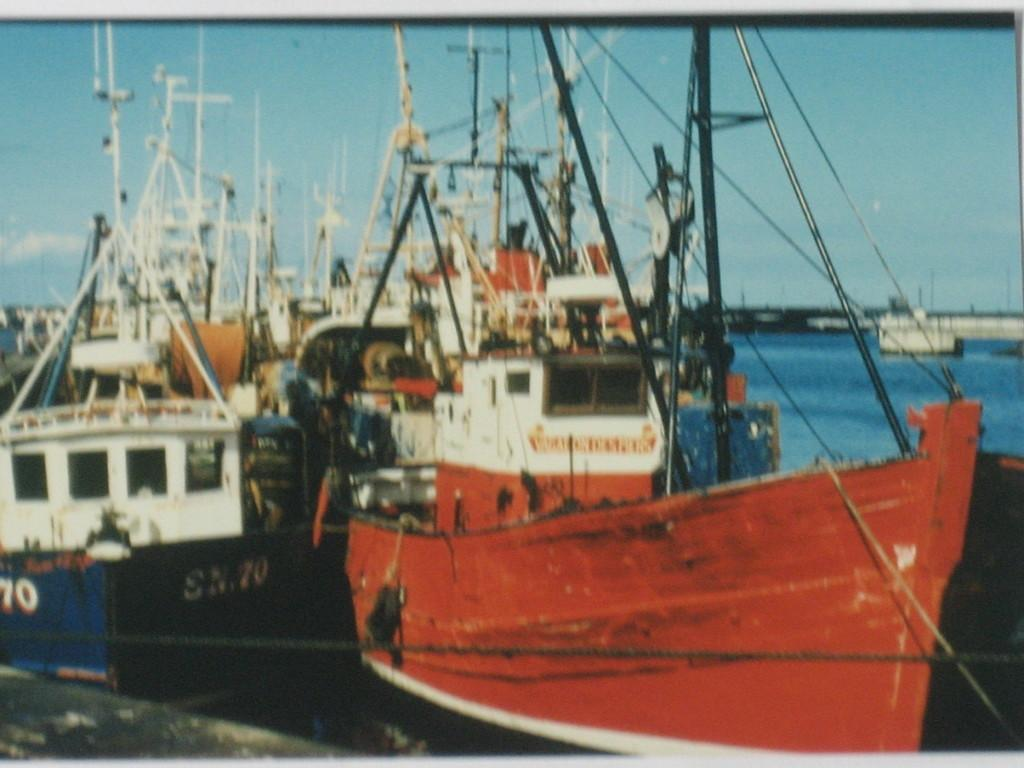<image>
Relay a brief, clear account of the picture shown. A few old sailboats floating in the water and the red one says SN70  on the side. 